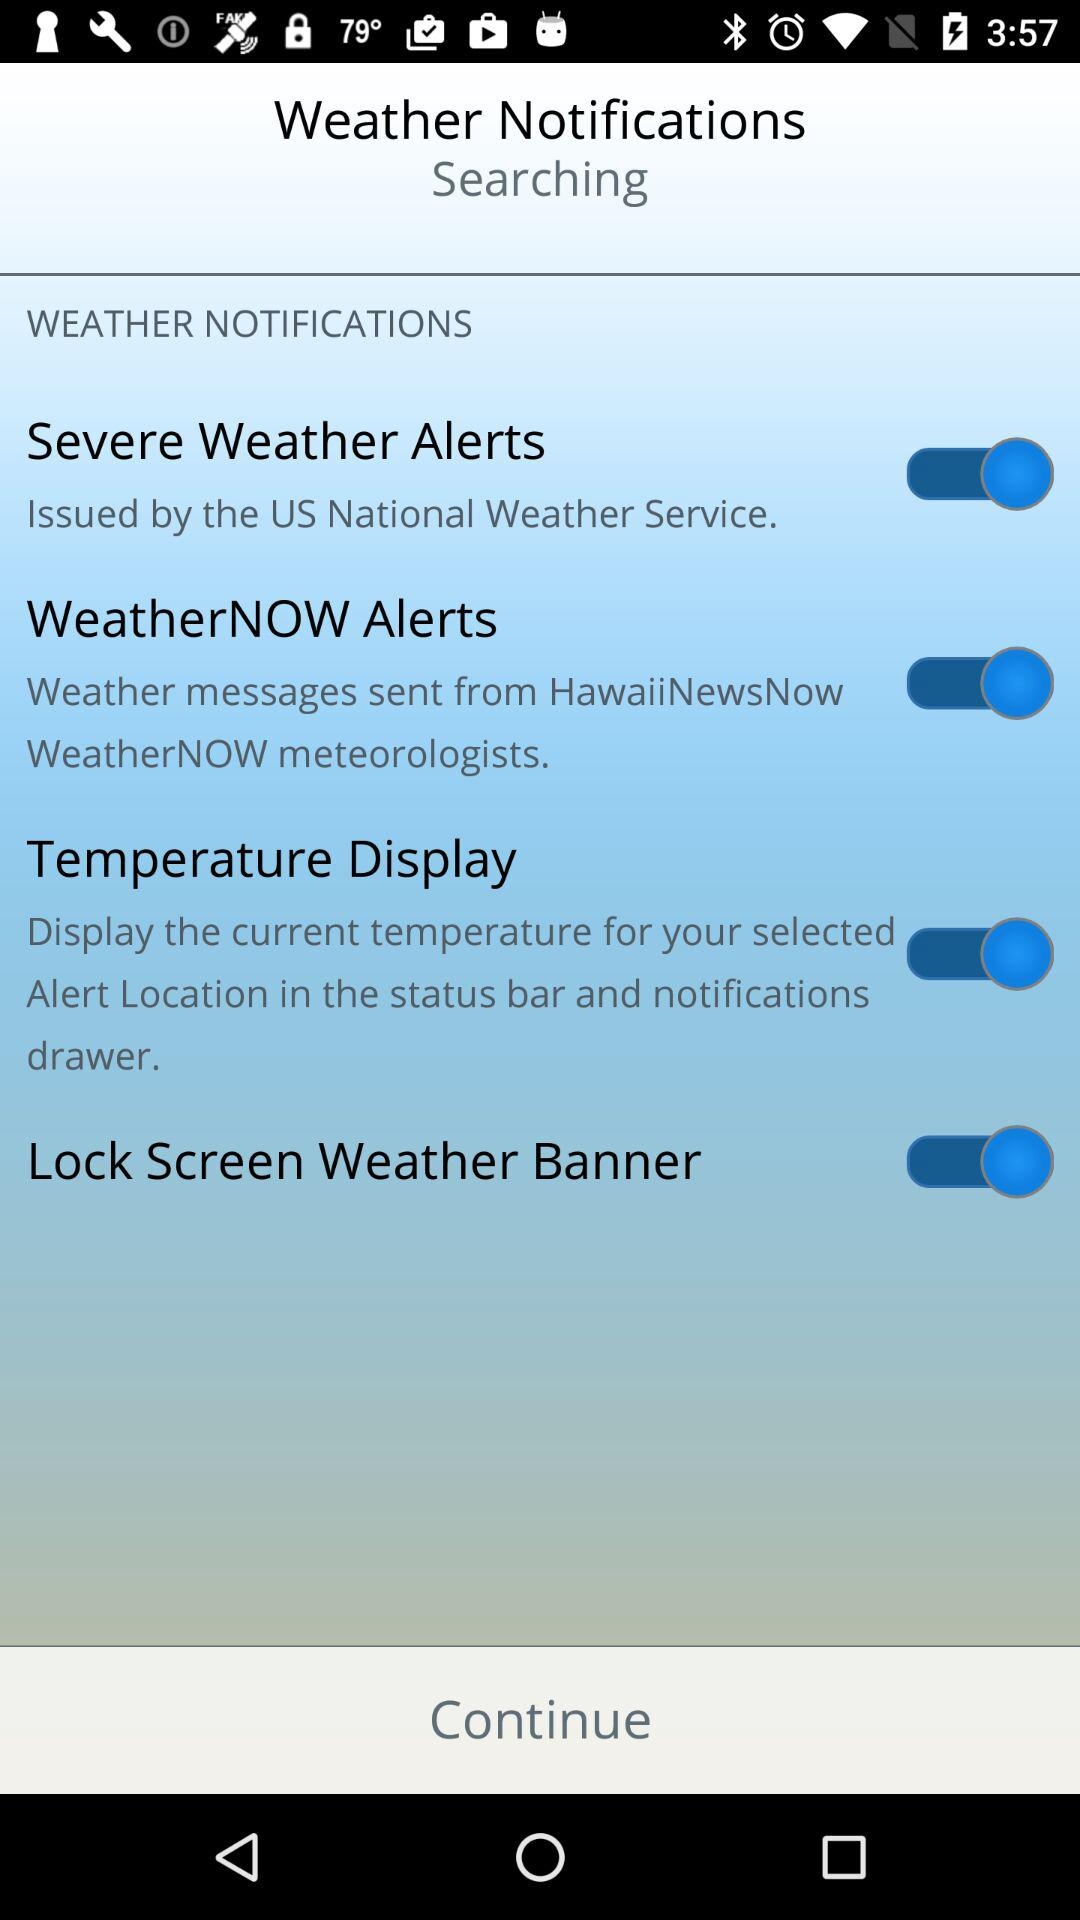What is the status of "Severe Weather Alerts"? The status of "Severe Weather Alerts" is "on". 